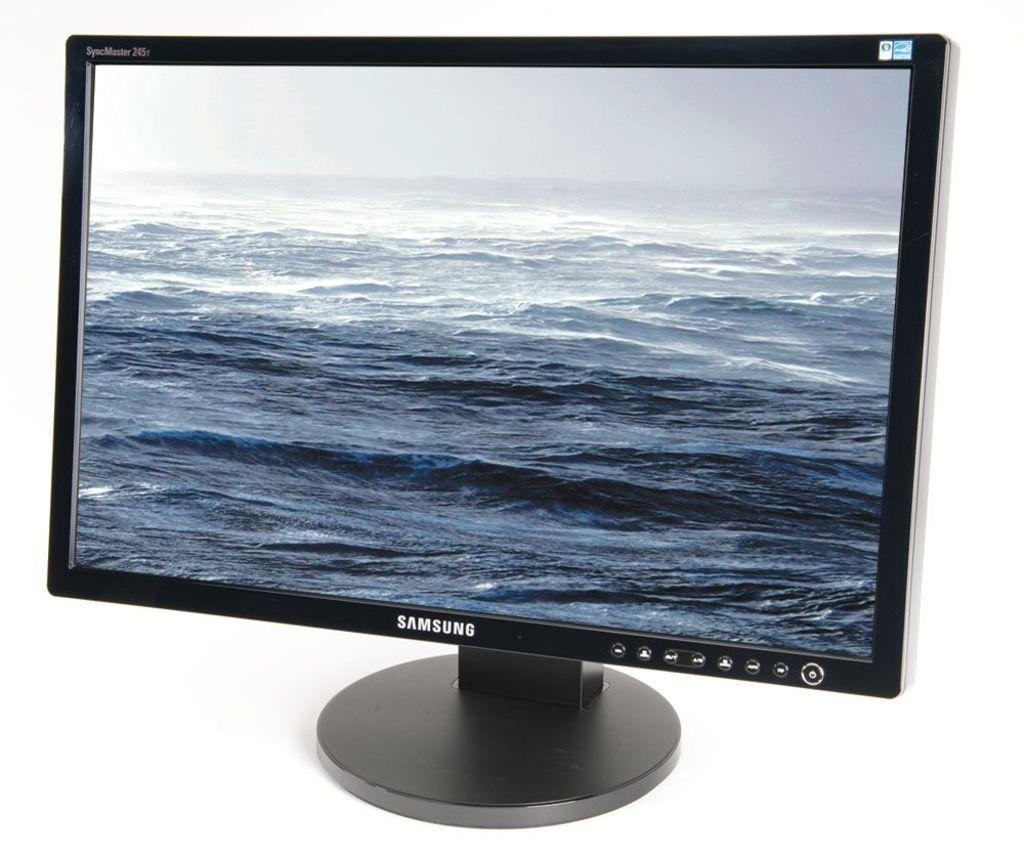<image>
Give a short and clear explanation of the subsequent image. A Samsung computer monitor has the ocean on its display. 